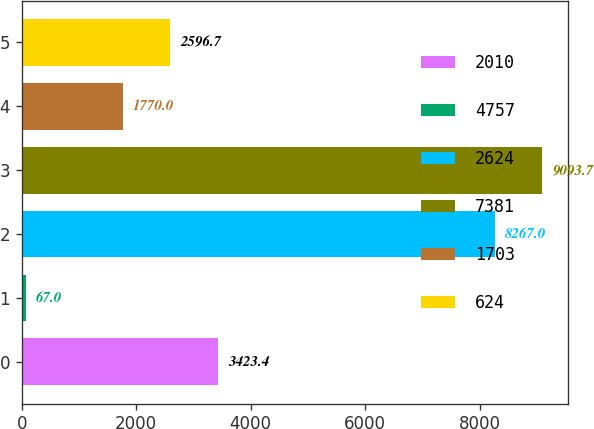Convert chart to OTSL. <chart><loc_0><loc_0><loc_500><loc_500><bar_chart><fcel>2010<fcel>4757<fcel>2624<fcel>7381<fcel>1703<fcel>624<nl><fcel>3423.4<fcel>67<fcel>8267<fcel>9093.7<fcel>1770<fcel>2596.7<nl></chart> 